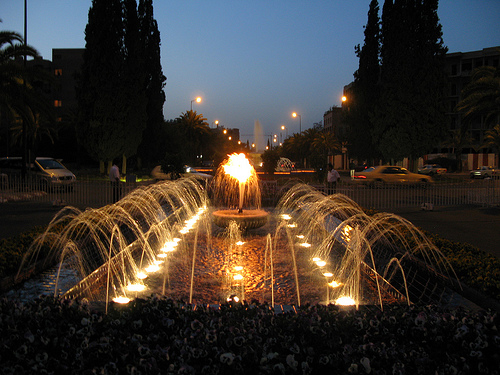<image>
Can you confirm if the fountain is next to the light? No. The fountain is not positioned next to the light. They are located in different areas of the scene. Is there a fountain in the street? Yes. The fountain is contained within or inside the street, showing a containment relationship. 